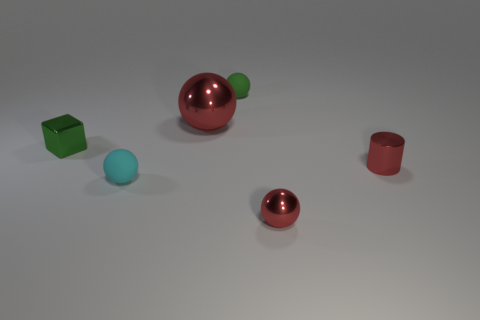Subtract all gray spheres. Subtract all green cylinders. How many spheres are left? 4 Add 2 tiny yellow rubber cubes. How many objects exist? 8 Subtract all cubes. How many objects are left? 5 Subtract 1 red cylinders. How many objects are left? 5 Subtract all tiny blue matte balls. Subtract all shiny balls. How many objects are left? 4 Add 1 small green metal blocks. How many small green metal blocks are left? 2 Add 3 big green objects. How many big green objects exist? 3 